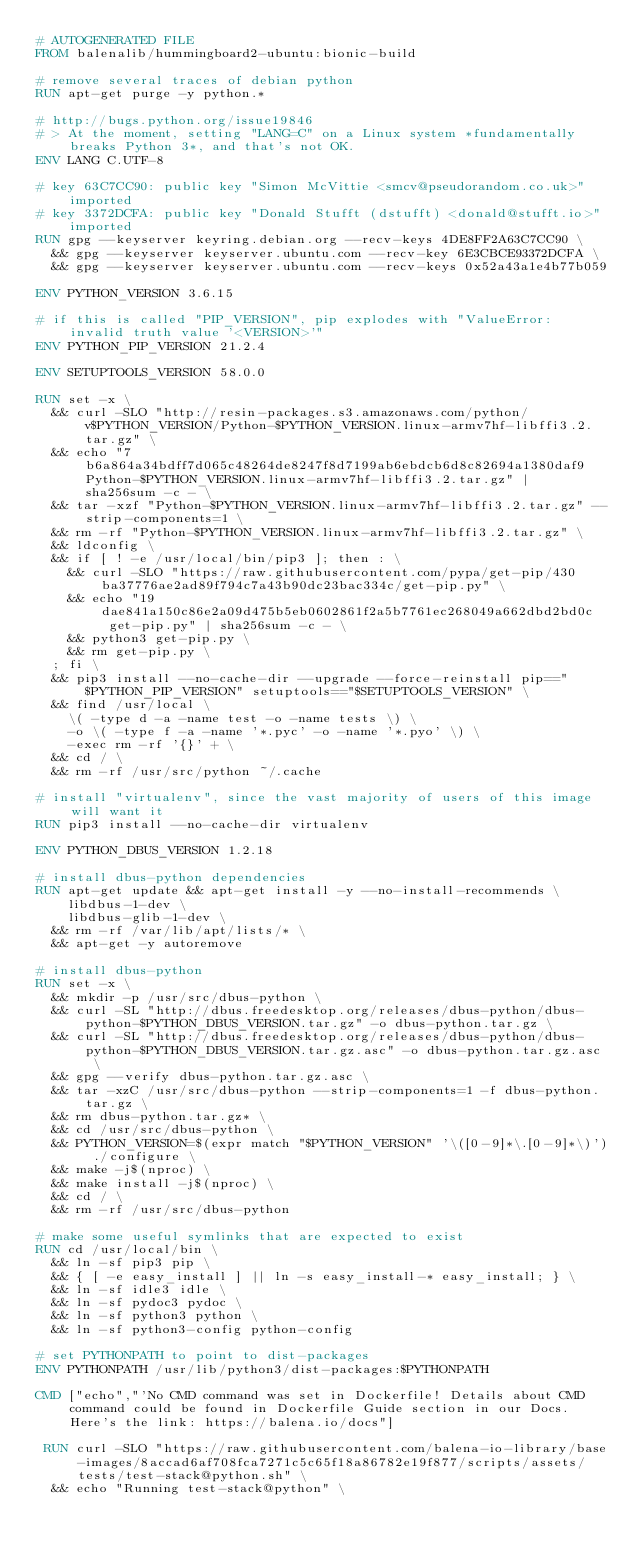Convert code to text. <code><loc_0><loc_0><loc_500><loc_500><_Dockerfile_># AUTOGENERATED FILE
FROM balenalib/hummingboard2-ubuntu:bionic-build

# remove several traces of debian python
RUN apt-get purge -y python.*

# http://bugs.python.org/issue19846
# > At the moment, setting "LANG=C" on a Linux system *fundamentally breaks Python 3*, and that's not OK.
ENV LANG C.UTF-8

# key 63C7CC90: public key "Simon McVittie <smcv@pseudorandom.co.uk>" imported
# key 3372DCFA: public key "Donald Stufft (dstufft) <donald@stufft.io>" imported
RUN gpg --keyserver keyring.debian.org --recv-keys 4DE8FF2A63C7CC90 \
	&& gpg --keyserver keyserver.ubuntu.com --recv-key 6E3CBCE93372DCFA \
	&& gpg --keyserver keyserver.ubuntu.com --recv-keys 0x52a43a1e4b77b059

ENV PYTHON_VERSION 3.6.15

# if this is called "PIP_VERSION", pip explodes with "ValueError: invalid truth value '<VERSION>'"
ENV PYTHON_PIP_VERSION 21.2.4

ENV SETUPTOOLS_VERSION 58.0.0

RUN set -x \
	&& curl -SLO "http://resin-packages.s3.amazonaws.com/python/v$PYTHON_VERSION/Python-$PYTHON_VERSION.linux-armv7hf-libffi3.2.tar.gz" \
	&& echo "7b6a864a34bdff7d065c48264de8247f8d7199ab6ebdcb6d8c82694a1380daf9  Python-$PYTHON_VERSION.linux-armv7hf-libffi3.2.tar.gz" | sha256sum -c - \
	&& tar -xzf "Python-$PYTHON_VERSION.linux-armv7hf-libffi3.2.tar.gz" --strip-components=1 \
	&& rm -rf "Python-$PYTHON_VERSION.linux-armv7hf-libffi3.2.tar.gz" \
	&& ldconfig \
	&& if [ ! -e /usr/local/bin/pip3 ]; then : \
		&& curl -SLO "https://raw.githubusercontent.com/pypa/get-pip/430ba37776ae2ad89f794c7a43b90dc23bac334c/get-pip.py" \
		&& echo "19dae841a150c86e2a09d475b5eb0602861f2a5b7761ec268049a662dbd2bd0c  get-pip.py" | sha256sum -c - \
		&& python3 get-pip.py \
		&& rm get-pip.py \
	; fi \
	&& pip3 install --no-cache-dir --upgrade --force-reinstall pip=="$PYTHON_PIP_VERSION" setuptools=="$SETUPTOOLS_VERSION" \
	&& find /usr/local \
		\( -type d -a -name test -o -name tests \) \
		-o \( -type f -a -name '*.pyc' -o -name '*.pyo' \) \
		-exec rm -rf '{}' + \
	&& cd / \
	&& rm -rf /usr/src/python ~/.cache

# install "virtualenv", since the vast majority of users of this image will want it
RUN pip3 install --no-cache-dir virtualenv

ENV PYTHON_DBUS_VERSION 1.2.18

# install dbus-python dependencies 
RUN apt-get update && apt-get install -y --no-install-recommends \
		libdbus-1-dev \
		libdbus-glib-1-dev \
	&& rm -rf /var/lib/apt/lists/* \
	&& apt-get -y autoremove

# install dbus-python
RUN set -x \
	&& mkdir -p /usr/src/dbus-python \
	&& curl -SL "http://dbus.freedesktop.org/releases/dbus-python/dbus-python-$PYTHON_DBUS_VERSION.tar.gz" -o dbus-python.tar.gz \
	&& curl -SL "http://dbus.freedesktop.org/releases/dbus-python/dbus-python-$PYTHON_DBUS_VERSION.tar.gz.asc" -o dbus-python.tar.gz.asc \
	&& gpg --verify dbus-python.tar.gz.asc \
	&& tar -xzC /usr/src/dbus-python --strip-components=1 -f dbus-python.tar.gz \
	&& rm dbus-python.tar.gz* \
	&& cd /usr/src/dbus-python \
	&& PYTHON_VERSION=$(expr match "$PYTHON_VERSION" '\([0-9]*\.[0-9]*\)') ./configure \
	&& make -j$(nproc) \
	&& make install -j$(nproc) \
	&& cd / \
	&& rm -rf /usr/src/dbus-python

# make some useful symlinks that are expected to exist
RUN cd /usr/local/bin \
	&& ln -sf pip3 pip \
	&& { [ -e easy_install ] || ln -s easy_install-* easy_install; } \
	&& ln -sf idle3 idle \
	&& ln -sf pydoc3 pydoc \
	&& ln -sf python3 python \
	&& ln -sf python3-config python-config

# set PYTHONPATH to point to dist-packages
ENV PYTHONPATH /usr/lib/python3/dist-packages:$PYTHONPATH

CMD ["echo","'No CMD command was set in Dockerfile! Details about CMD command could be found in Dockerfile Guide section in our Docs. Here's the link: https://balena.io/docs"]

 RUN curl -SLO "https://raw.githubusercontent.com/balena-io-library/base-images/8accad6af708fca7271c5c65f18a86782e19f877/scripts/assets/tests/test-stack@python.sh" \
  && echo "Running test-stack@python" \</code> 